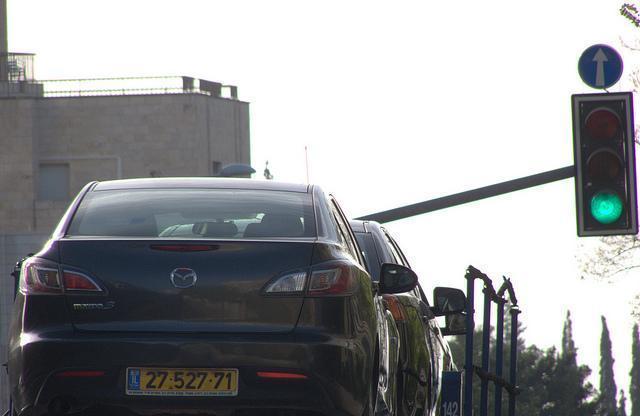How many cars can be seen?
Give a very brief answer. 2. 